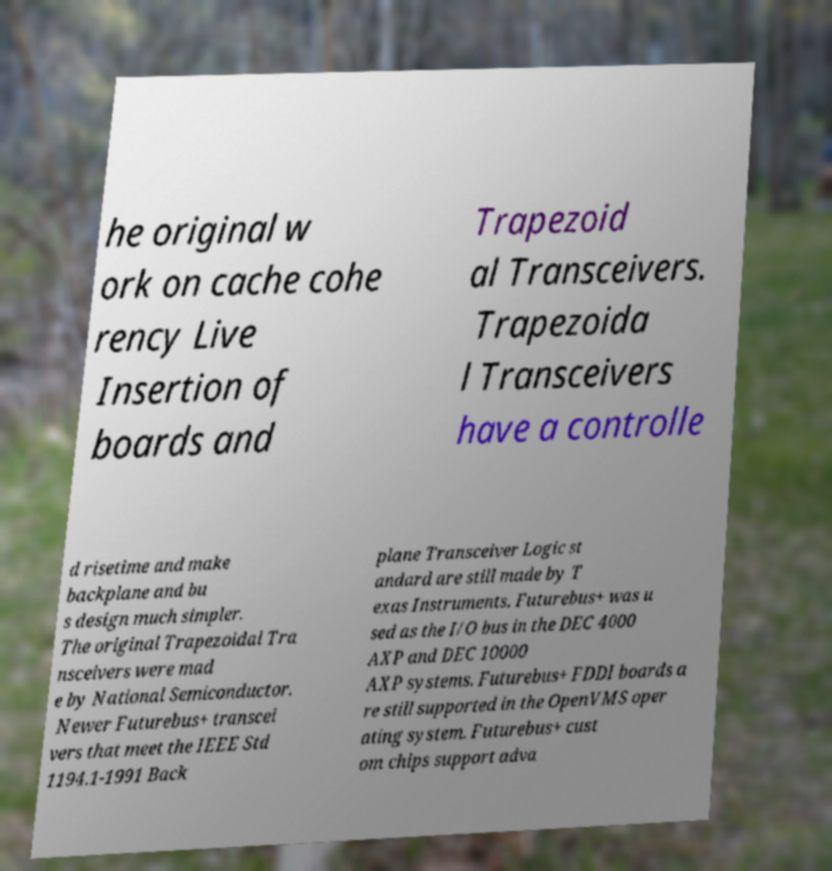Can you accurately transcribe the text from the provided image for me? he original w ork on cache cohe rency Live Insertion of boards and Trapezoid al Transceivers. Trapezoida l Transceivers have a controlle d risetime and make backplane and bu s design much simpler. The original Trapezoidal Tra nsceivers were mad e by National Semiconductor. Newer Futurebus+ transcei vers that meet the IEEE Std 1194.1-1991 Back plane Transceiver Logic st andard are still made by T exas Instruments. Futurebus+ was u sed as the I/O bus in the DEC 4000 AXP and DEC 10000 AXP systems. Futurebus+ FDDI boards a re still supported in the OpenVMS oper ating system. Futurebus+ cust om chips support adva 